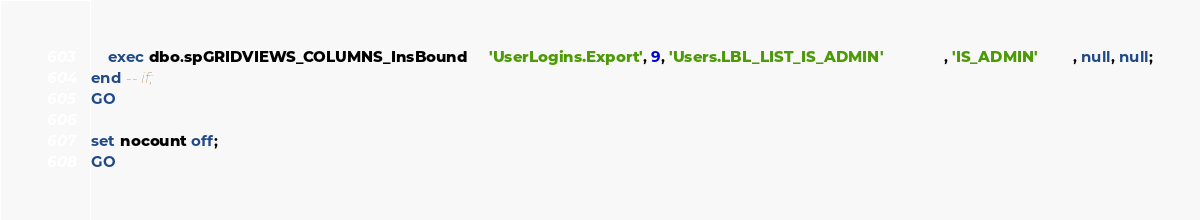<code> <loc_0><loc_0><loc_500><loc_500><_SQL_>	exec dbo.spGRIDVIEWS_COLUMNS_InsBound     'UserLogins.Export', 9, 'Users.LBL_LIST_IS_ADMIN'              , 'IS_ADMIN'        , null, null;
end -- if;
GO

set nocount off;
GO


</code> 